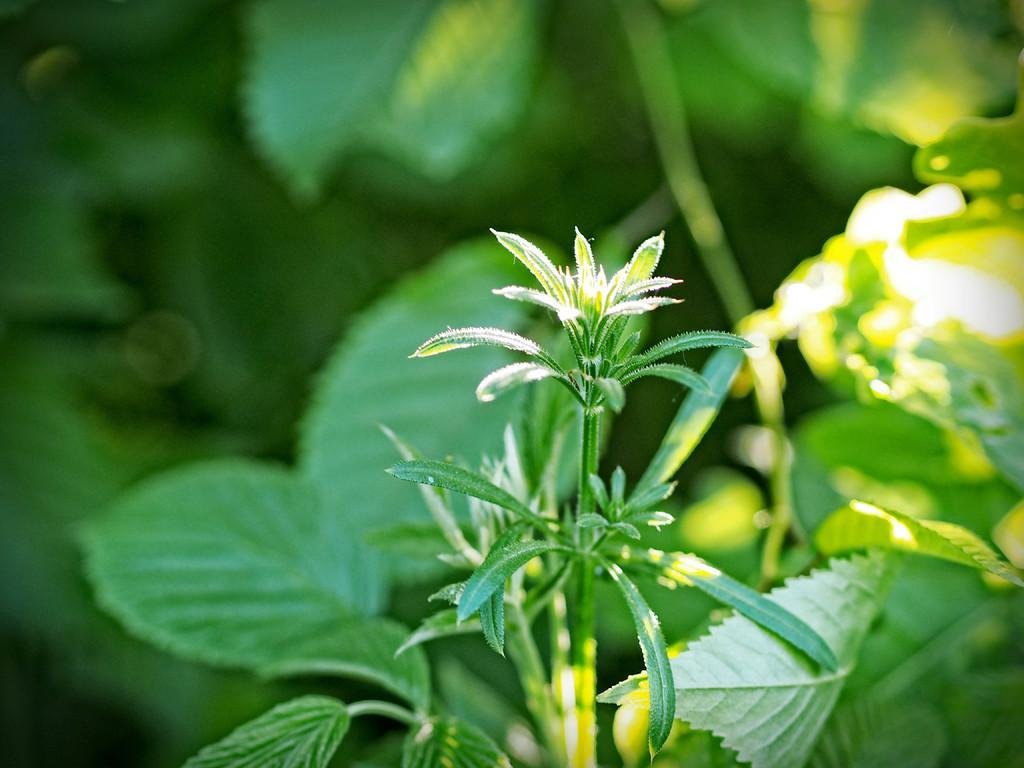Could you give a brief overview of what you see in this image? In this image we can see some plants and the background is blurred. 